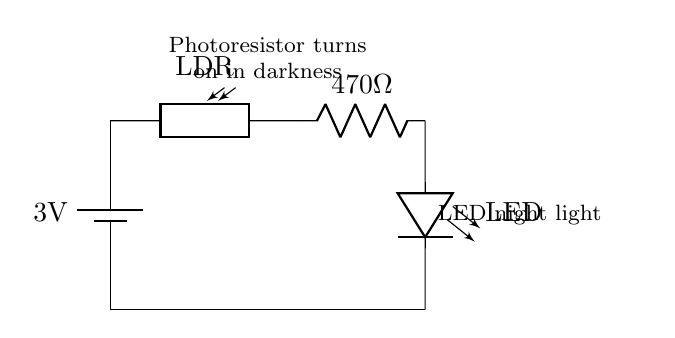What is the power supply voltage? The circuit diagram shows a battery marked as 3V, indicating that is the voltage providing power to the circuit.
Answer: 3V What type of light sensor is used in this circuit? The circuit uses a photoresistor (LDR), which is a light-dependent resistor that changes its resistance based on the light intensity.
Answer: Photoresistor What is the resistance value of the resistor? The diagram specifies a resistor with a value of 470 ohms, which is labeled directly in the circuit representation.
Answer: 470 ohms What happens to the LED in darkness? The photoresistor detects low light conditions and reduces its resistance, allowing current to flow through the circuit and turn on the LED.
Answer: Turns on Which component is responsible for controlling the LED based on light levels? The photoresistor acts as the control element, automatically switching the LED on or off depending on the surrounding light conditions.
Answer: Photoresistor How does the circuit behave in bright light? In bright light, the photoresistor has a low resistance, which stops the current flow in this specific arrangement and turns off the LED.
Answer: Turns off Why is the LED connected in series with the resistor? The resistor is placed in series with the LED to limit the current flowing to the LED, protecting it from excess current that could cause damage.
Answer: To limit current 